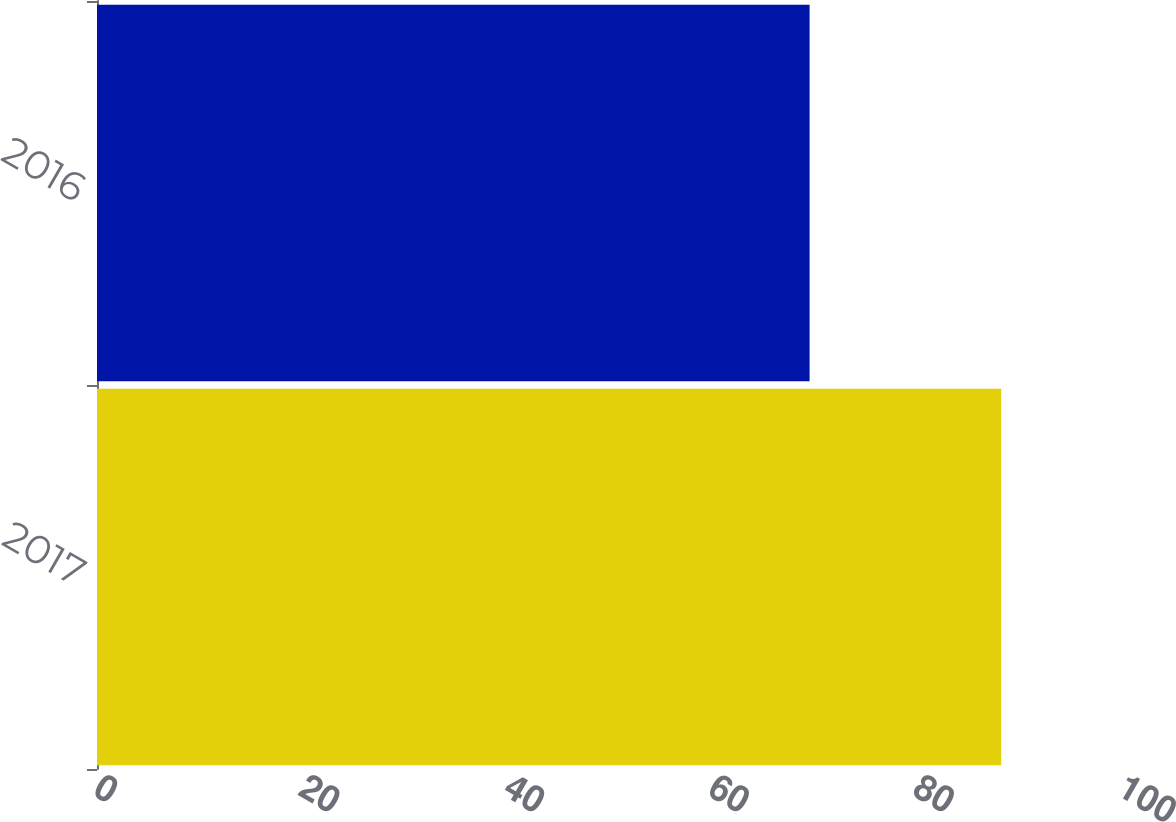<chart> <loc_0><loc_0><loc_500><loc_500><bar_chart><fcel>2017<fcel>2016<nl><fcel>88.3<fcel>69.59<nl></chart> 